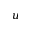Convert formula to latex. <formula><loc_0><loc_0><loc_500><loc_500>u</formula> 